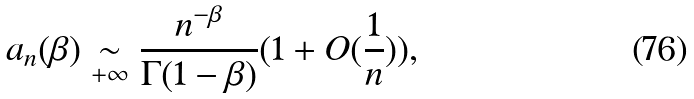Convert formula to latex. <formula><loc_0><loc_0><loc_500><loc_500>a _ { n } ( \beta ) \underset { + \infty } \sim \frac { n ^ { - \beta } } { \Gamma ( 1 - \beta ) } ( 1 + O ( \frac { 1 } { n } ) ) ,</formula> 